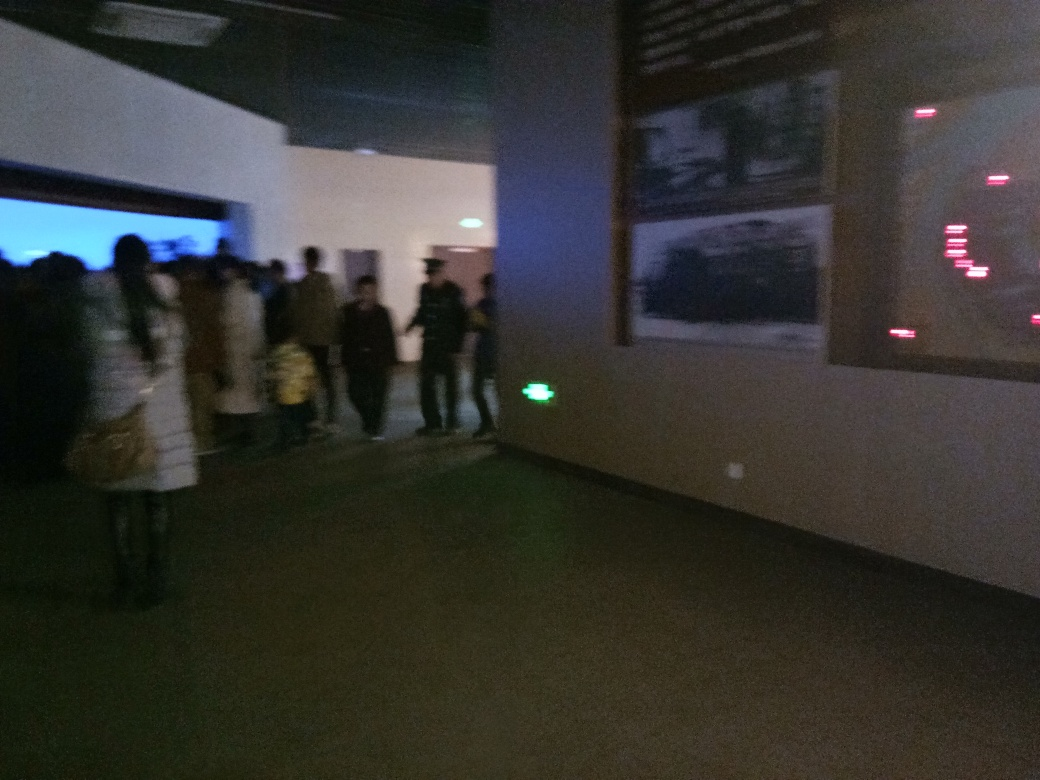Are there any specific details in the image that stand out to you? Despite the blurriness, some specific details that stand out include the bright green exit sign to the left of the frame, which contrasts with the darker surroundings, and the illuminated area towards the middle of the crowd, possibly indicating the presence of a display or screen that is drawing the crowd's attention. 